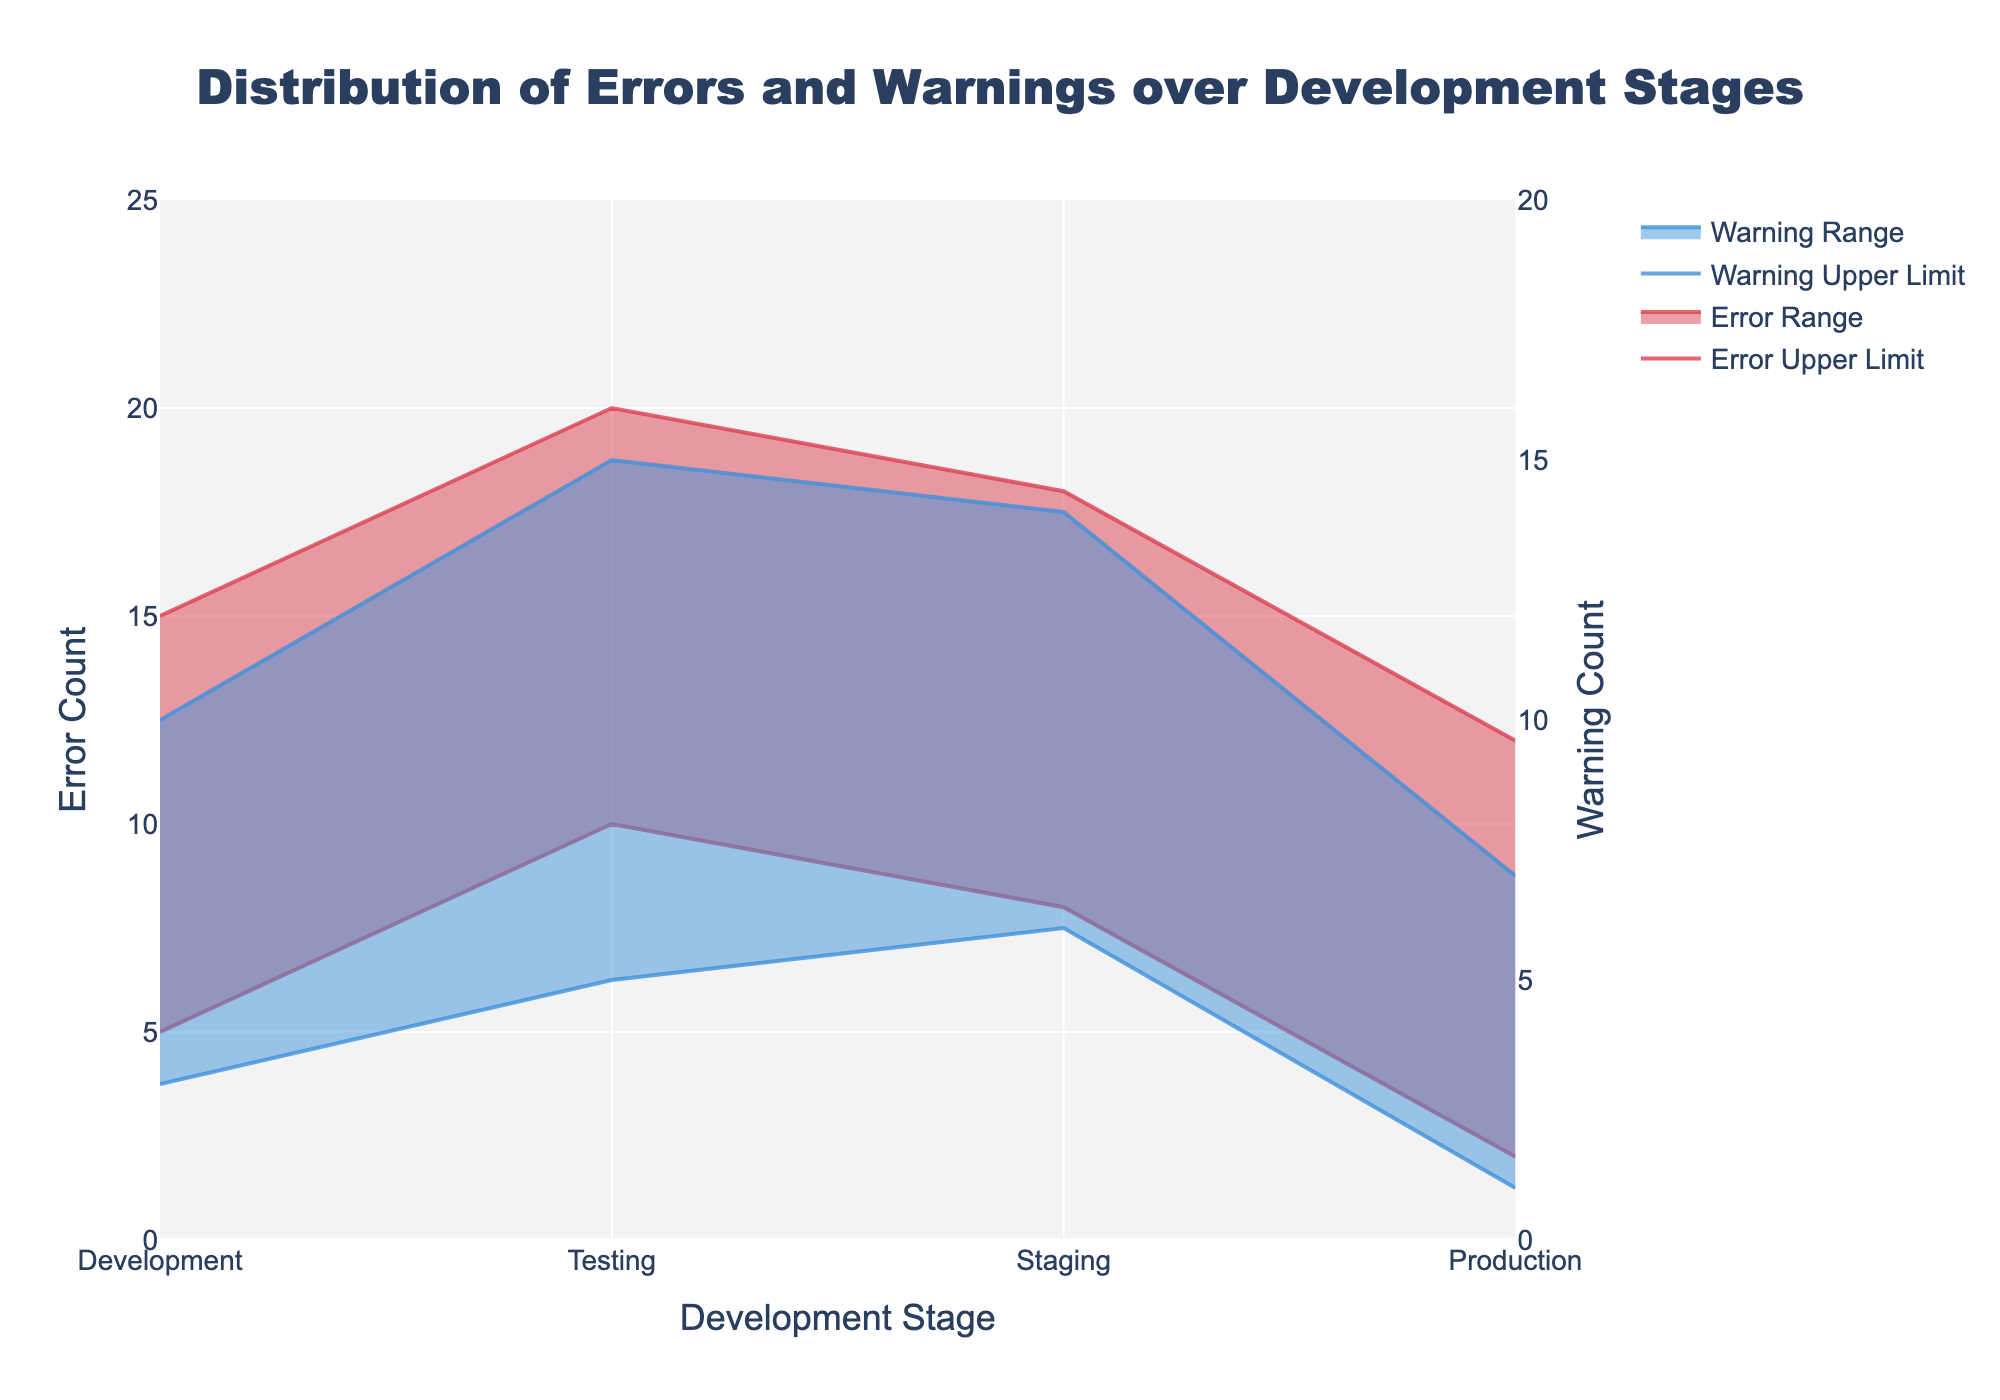What is the title of the figure? The title can be found at the top of the figure. It provides a summary of what the figure represents. Here, it is "Distribution of Errors and Warnings over Development Stages".
Answer: Distribution of Errors and Warnings over Development Stages How many stages are presented in the figure? Count the different stages labeled on the x-axis. The stages are "Development", "Testing", "Staging", and "Production". This gives us four stages.
Answer: Four What color represents the error range and its upper and lower limits? Identify the color used for the error range and its boundaries in the figure. The error range and its limits are shown in shades of red.
Answer: Red During which stage is the upper limit of errors the highest? Look at the highest point of the red-filled range for the errors across all stages. The highest point for errors is during the "Testing" stage.
Answer: Testing What is the warning lower limit in the Production stage? Examine the y-axis data for warnings (using the right-hand side y-axis) at the "Production" stage. The lower limit is marked as '1' for this stage.
Answer: 1 By how much does the error upper limit decrease from Testing to Production? Check the upper limit values of the error range at both the "Testing" and "Production" stages. The difference is 20 (Testing) - 12 (Production) which equates to 8.
Answer: 8 In what stage is the smallest gap between the warning lower and upper limits observed? Calculate the difference between the upper and lower limits of warnings for each stage. The smallest gap is seen at the "Production" (7 - 1 = 6).
Answer: Production Which stage shows a higher upper limit for warnings than errors? Compare the upper limit values for warnings and errors at each stage. At the "Testing" stage, the upper limit for warnings (15) is less than the errors (20). At the other stages, the upper limit for warnings is lower than errors. No stage shows a higher upper limit for warnings.
Answer: None How do the error counts change from Development to Staging stages? Observe the trend in the red error bands from "Development" to "Staging". The upper and lower limits of errors both increase slightly from "Development" to "Testing" and then decrease slightly from "Testing" to "Staging". So the overall trend is stable.
Answer: Stable Which stage has the highest gap between error lower limit and warning upper limit? Calculate the gap for each stage by checking the values at the lower limit of errors and comparing them to the upper limit of warnings. The "Development" stage shows the highest difference with 15 (errors) - 3 (warnings) = 12.
Answer: Development 